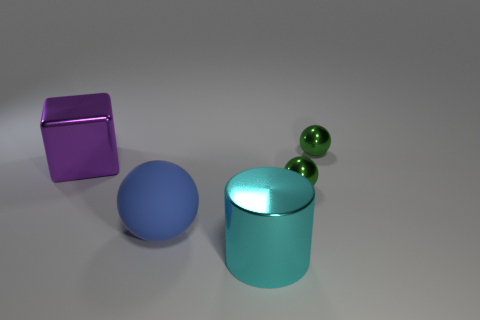Are there fewer green shiny spheres that are in front of the cube than metal balls that are on the left side of the cyan metallic cylinder?
Your response must be concise. No. How many green objects are either large metal cylinders or small balls?
Keep it short and to the point. 2. Are there an equal number of blue matte objects that are to the right of the large cylinder and big metal things?
Your answer should be very brief. No. What number of objects are either green things or large shiny things to the left of the cyan object?
Offer a terse response. 3. Do the rubber object and the metal cube have the same color?
Ensure brevity in your answer.  No. Are there any spheres made of the same material as the cube?
Your answer should be compact. Yes. Do the cyan cylinder and the ball that is left of the big cyan cylinder have the same material?
Your answer should be very brief. No. There is a metallic object that is on the left side of the big shiny object that is in front of the rubber ball; what is its shape?
Your answer should be very brief. Cube. There is a green ball in front of the purple metal cube; is it the same size as the blue matte object?
Make the answer very short. No. What number of other things are there of the same shape as the blue rubber thing?
Make the answer very short. 2. 